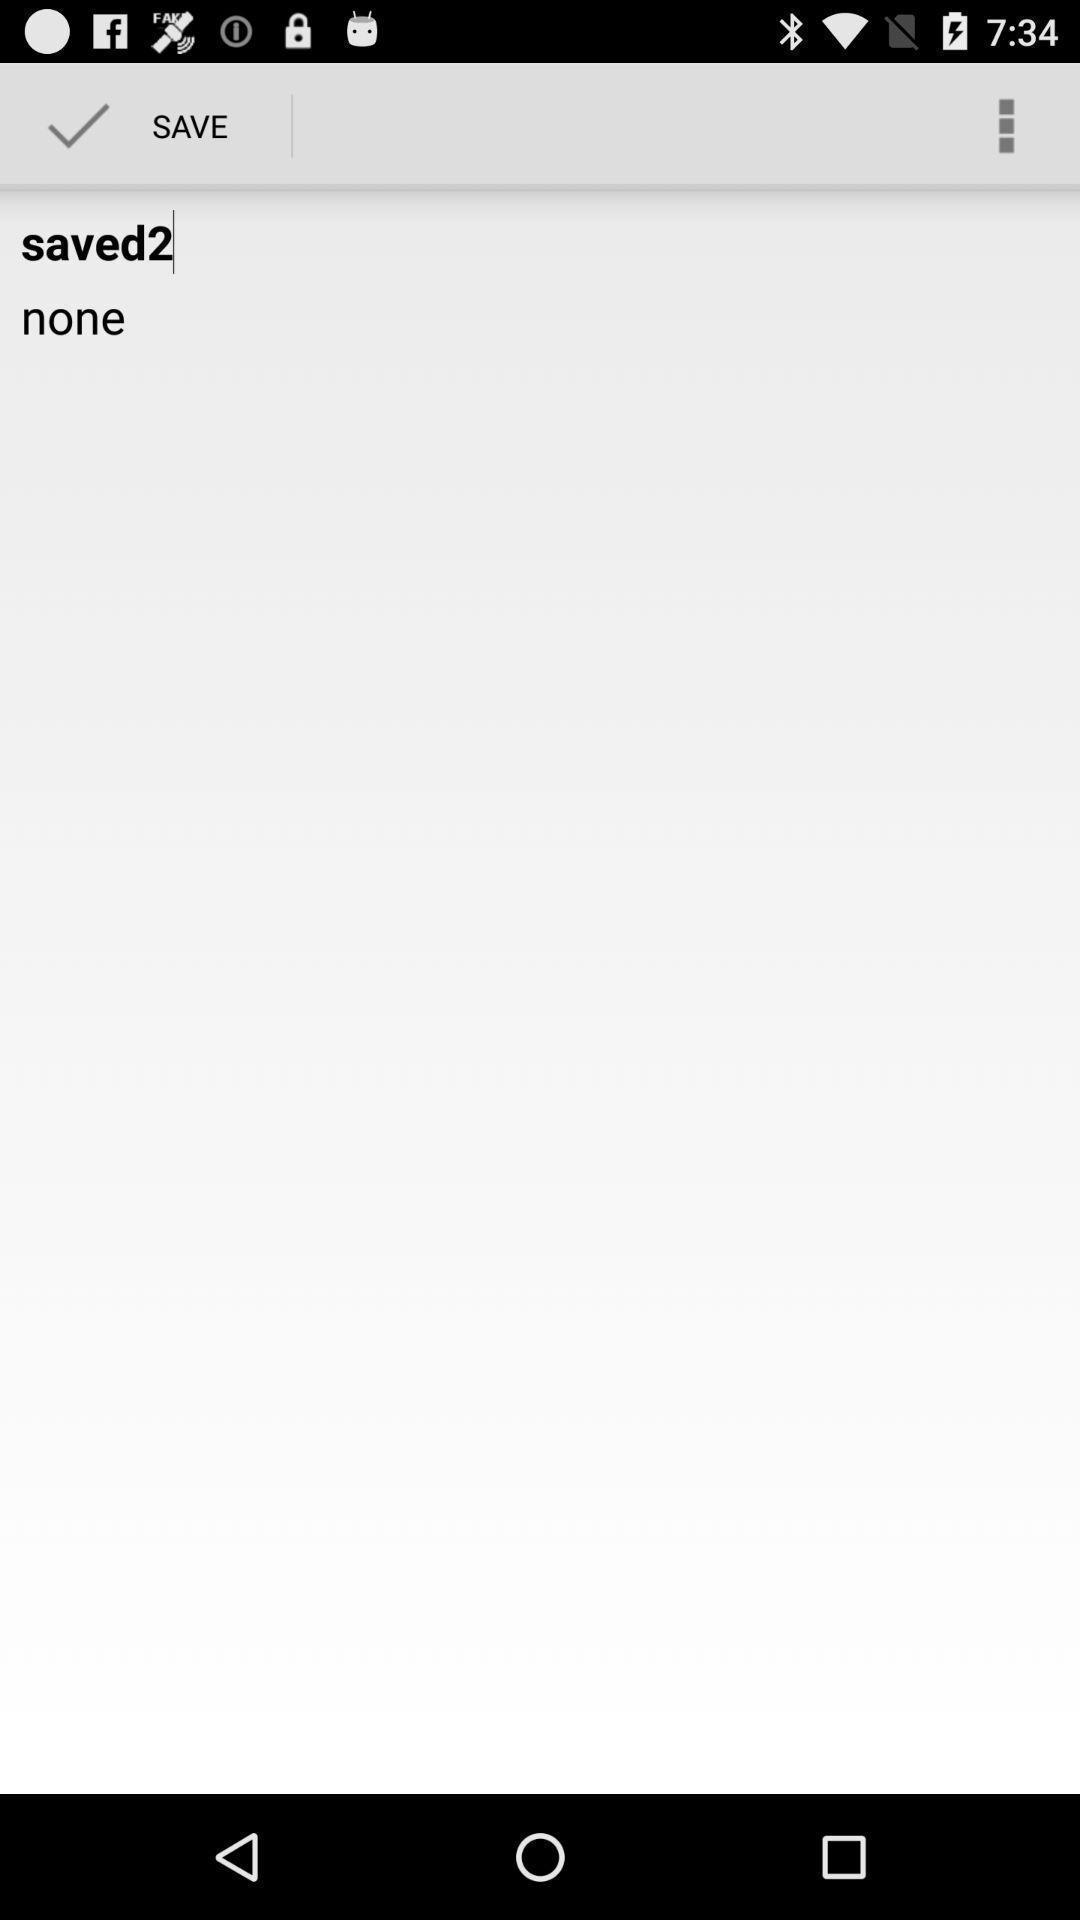Provide a detailed account of this screenshot. Screen shows save option for an application. 